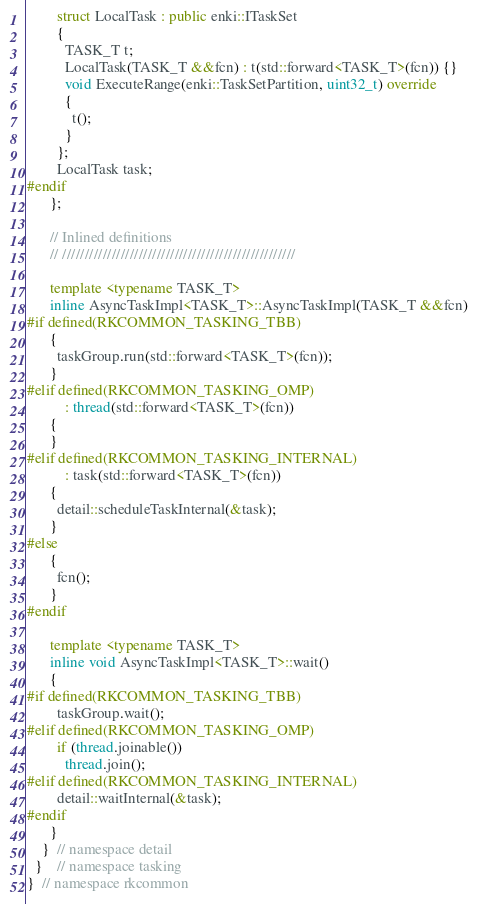Convert code to text. <code><loc_0><loc_0><loc_500><loc_500><_C++_>        struct LocalTask : public enki::ITaskSet
        {
          TASK_T t;
          LocalTask(TASK_T &&fcn) : t(std::forward<TASK_T>(fcn)) {}
          void ExecuteRange(enki::TaskSetPartition, uint32_t) override
          {
            t();
          }
        };
        LocalTask task;
#endif
      };

      // Inlined definitions
      // ////////////////////////////////////////////////////

      template <typename TASK_T>
      inline AsyncTaskImpl<TASK_T>::AsyncTaskImpl(TASK_T &&fcn)
#if defined(RKCOMMON_TASKING_TBB)
      {
        taskGroup.run(std::forward<TASK_T>(fcn));
      }
#elif defined(RKCOMMON_TASKING_OMP)
          : thread(std::forward<TASK_T>(fcn))
      {
      }
#elif defined(RKCOMMON_TASKING_INTERNAL)
          : task(std::forward<TASK_T>(fcn))
      {
        detail::scheduleTaskInternal(&task);
      }
#else
      {
        fcn();
      }
#endif

      template <typename TASK_T>
      inline void AsyncTaskImpl<TASK_T>::wait()
      {
#if defined(RKCOMMON_TASKING_TBB)
        taskGroup.wait();
#elif defined(RKCOMMON_TASKING_OMP)
        if (thread.joinable())
          thread.join();
#elif defined(RKCOMMON_TASKING_INTERNAL)
        detail::waitInternal(&task);
#endif
      }
    }  // namespace detail
  }    // namespace tasking
}  // namespace rkcommon
</code> 